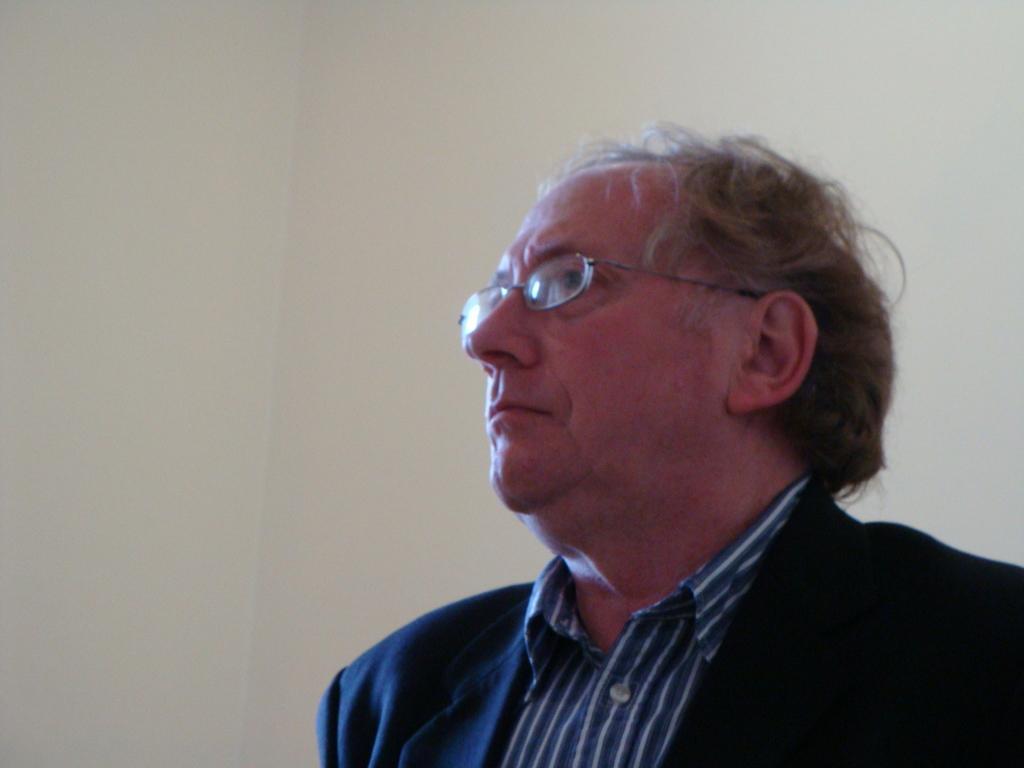Please provide a concise description of this image. In this image in the front there is a person. In the background there is a wall. 